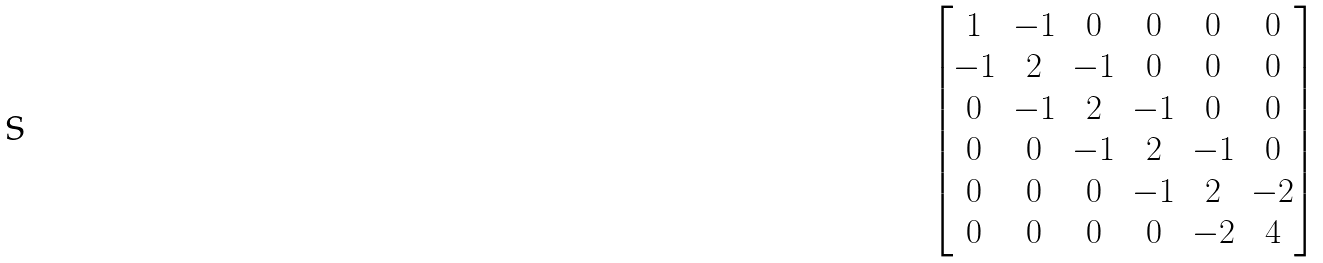<formula> <loc_0><loc_0><loc_500><loc_500>\begin{bmatrix} 1 & - 1 & 0 & 0 & 0 & 0 \\ - 1 & 2 & - 1 & 0 & 0 & 0 \\ 0 & - 1 & 2 & - 1 & 0 & 0 \\ 0 & 0 & - 1 & 2 & - 1 & 0 \\ 0 & 0 & 0 & - 1 & 2 & - 2 \\ 0 & 0 & 0 & 0 & - 2 & 4 \end{bmatrix}</formula> 